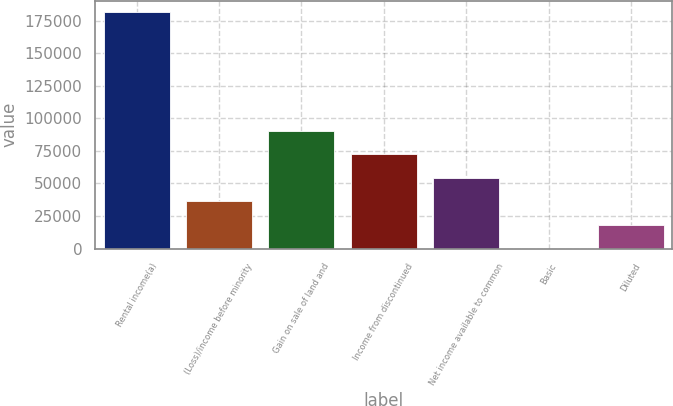Convert chart. <chart><loc_0><loc_0><loc_500><loc_500><bar_chart><fcel>Rental income(a)<fcel>(Loss)/income before minority<fcel>Gain on sale of land and<fcel>Income from discontinued<fcel>Net income available to common<fcel>Basic<fcel>Diluted<nl><fcel>181145<fcel>36229.2<fcel>90572.6<fcel>72458.1<fcel>54343.7<fcel>0.21<fcel>18114.7<nl></chart> 